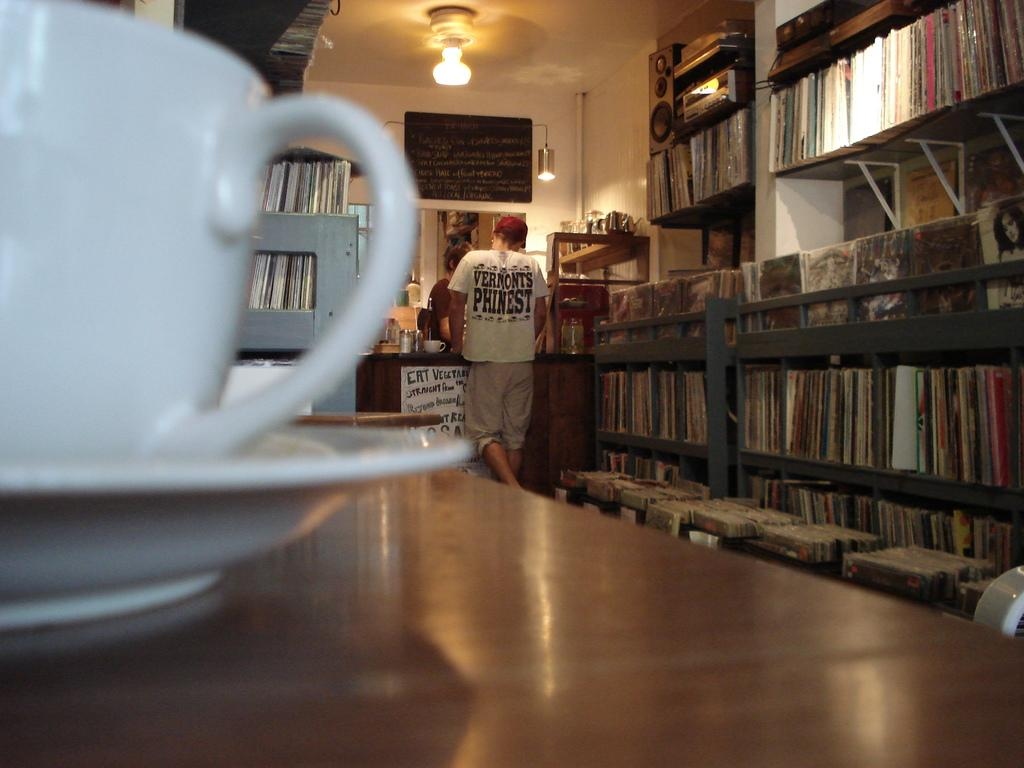<image>
Render a clear and concise summary of the photo. A far away shot of a man at a checkout counter with a sign that says "Eat Vegetables" on it 